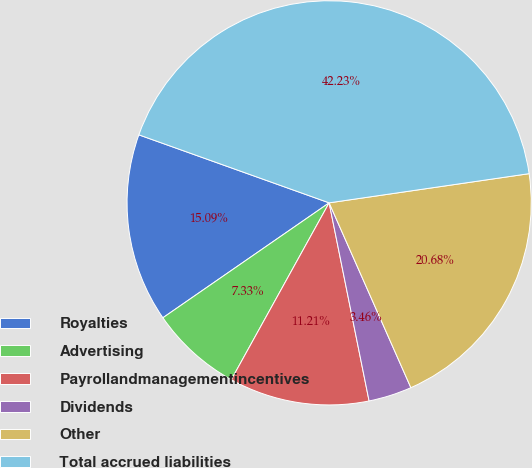Convert chart to OTSL. <chart><loc_0><loc_0><loc_500><loc_500><pie_chart><fcel>Royalties<fcel>Advertising<fcel>Payrollandmanagementincentives<fcel>Dividends<fcel>Other<fcel>Total accrued liabilities<nl><fcel>15.09%<fcel>7.33%<fcel>11.21%<fcel>3.46%<fcel>20.68%<fcel>42.23%<nl></chart> 